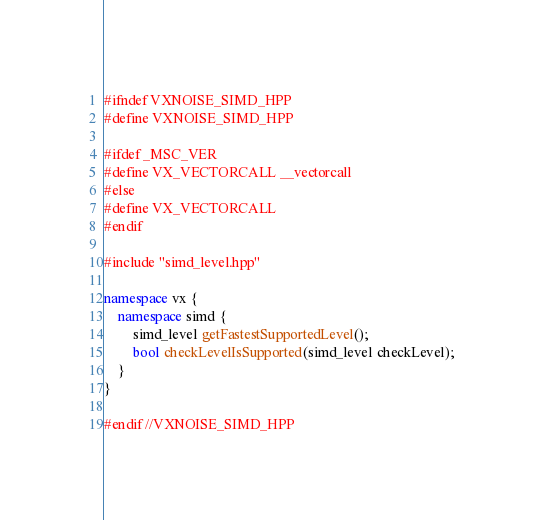<code> <loc_0><loc_0><loc_500><loc_500><_C++_>#ifndef VXNOISE_SIMD_HPP
#define VXNOISE_SIMD_HPP

#ifdef _MSC_VER
#define VX_VECTORCALL __vectorcall
#else
#define VX_VECTORCALL
#endif

#include "simd_level.hpp"

namespace vx {
    namespace simd {
        simd_level getFastestSupportedLevel();
        bool checkLevelIsSupported(simd_level checkLevel);
    }
}

#endif //VXNOISE_SIMD_HPP
</code> 